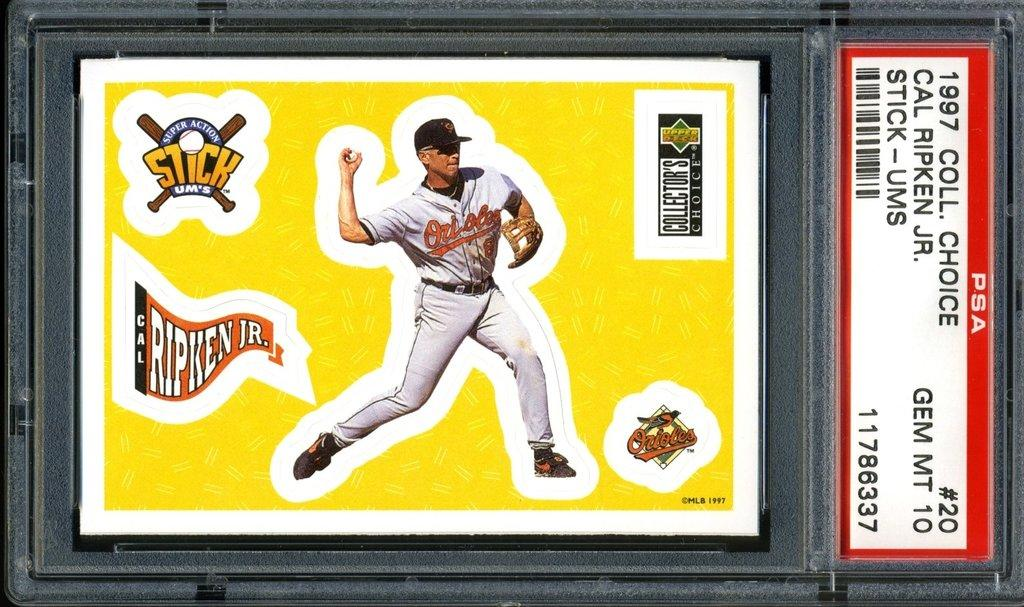<image>
Present a compact description of the photo's key features. A 1997 Cal Ripken Jr baseball card in a PSA case. 